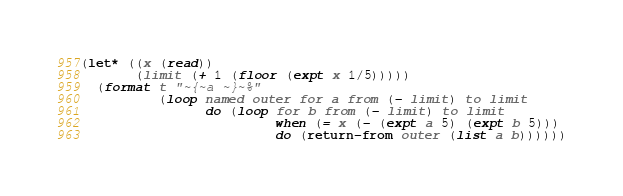Convert code to text. <code><loc_0><loc_0><loc_500><loc_500><_Lisp_>(let* ((x (read))
       (limit (+ 1 (floor (expt x 1/5)))))
  (format t "~{~a ~}~%"
          (loop named outer for a from (- limit) to limit
                do (loop for b from (- limit) to limit
                         when (= x (- (expt a 5) (expt b 5)))
                         do (return-from outer (list a b))))))
</code> 